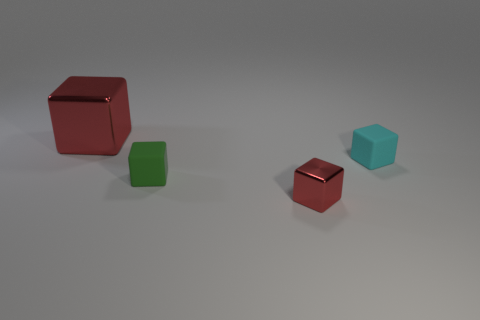How big is the thing that is both behind the green thing and right of the green block?
Offer a terse response. Small. What number of metallic objects are either small objects or green blocks?
Give a very brief answer. 1. Are there more large metallic cubes behind the big red metallic cube than small red objects?
Offer a very short reply. No. What is the red cube that is in front of the cyan rubber object made of?
Offer a terse response. Metal. How many yellow balls are the same material as the tiny red thing?
Ensure brevity in your answer.  0. There is a thing that is both to the right of the tiny green object and in front of the tiny cyan thing; what is its shape?
Your answer should be compact. Cube. What number of things are either small matte things in front of the cyan block or rubber objects left of the small red cube?
Offer a terse response. 1. Are there an equal number of red things that are in front of the small green cube and cyan matte objects that are on the left side of the small red shiny thing?
Make the answer very short. No. The red thing right of the red block that is behind the green matte object is what shape?
Your response must be concise. Cube. Is there a cyan rubber thing of the same shape as the small red thing?
Offer a terse response. Yes. 